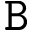Convert formula to latex. <formula><loc_0><loc_0><loc_500><loc_500>{ \tt B }</formula> 